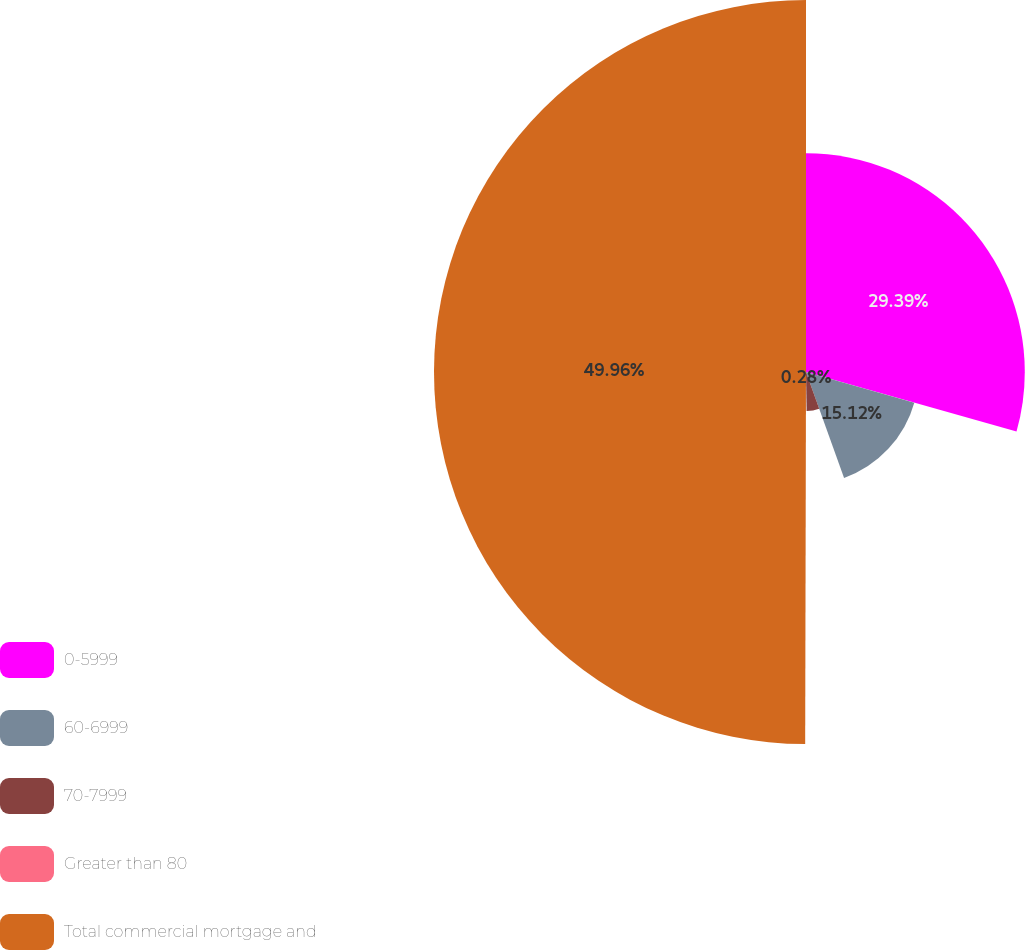<chart> <loc_0><loc_0><loc_500><loc_500><pie_chart><fcel>0-5999<fcel>60-6999<fcel>70-7999<fcel>Greater than 80<fcel>Total commercial mortgage and<nl><fcel>29.39%<fcel>15.12%<fcel>5.25%<fcel>0.28%<fcel>49.97%<nl></chart> 